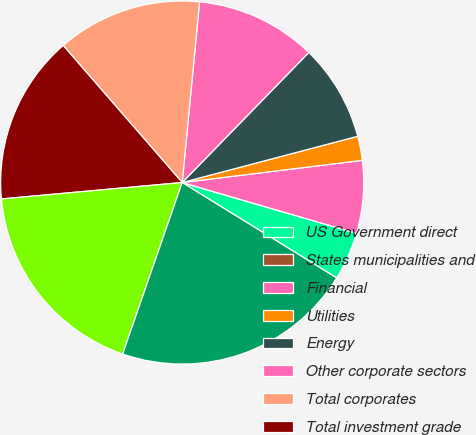<chart> <loc_0><loc_0><loc_500><loc_500><pie_chart><fcel>US Government direct<fcel>States municipalities and<fcel>Financial<fcel>Utilities<fcel>Energy<fcel>Other corporate sectors<fcel>Total corporates<fcel>Total investment grade<fcel>Total below investment grade<fcel>Total fixed maturities<nl><fcel>4.3%<fcel>0.0%<fcel>6.46%<fcel>2.15%<fcel>8.61%<fcel>10.76%<fcel>12.91%<fcel>15.06%<fcel>18.24%<fcel>21.51%<nl></chart> 